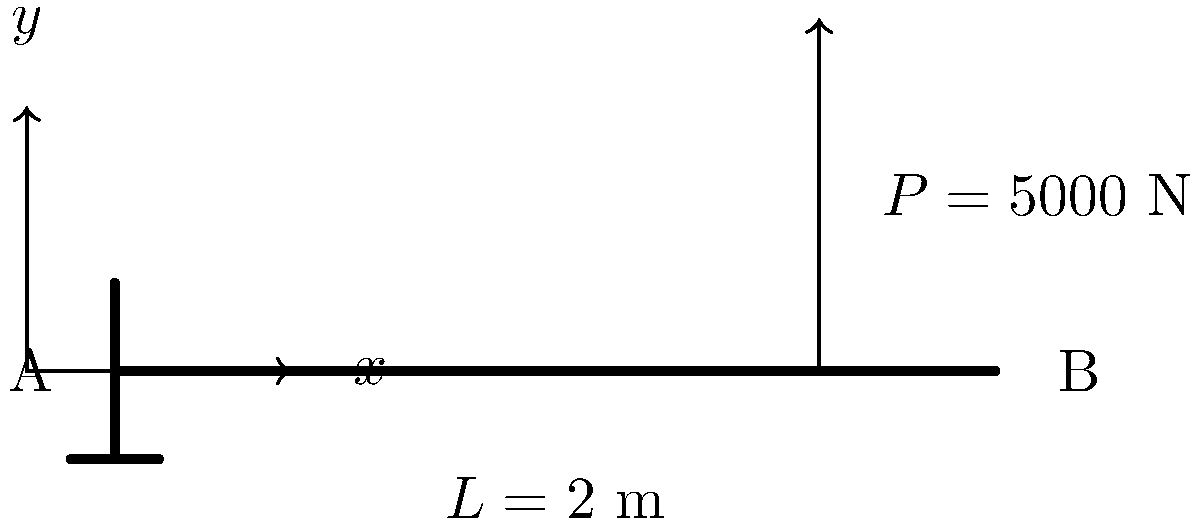As a business owner concerned with transparency in government contracts, you're reviewing a structural analysis report for a public building project. The report includes a problem involving a cantilever beam with a point load, as shown in the diagram. If the beam is made of steel with a yield strength of 250 MPa and a rectangular cross-section of 100 mm width and 200 mm height, determine the maximum bending stress at the fixed end (point A). Is the beam design safe with a factor of safety of 2? Let's approach this step-by-step:

1) First, we need to calculate the maximum bending moment. For a cantilever beam with a point load P at distance L from the fixed end:

   $M_{max} = PL$

   Where P = 5000 N and L = 2 m
   
   $M_{max} = 5000 \text{ N} \times 2 \text{ m} = 10000 \text{ N}\cdot\text{m}$

2) Next, we calculate the moment of inertia (I) for the rectangular cross-section:

   $I = \frac{bh^3}{12}$

   Where b = 100 mm and h = 200 mm

   $I = \frac{100 \text{ mm} \times (200 \text{ mm})^3}{12} = 66.67 \times 10^6 \text{ mm}^4$

3) Now we can calculate the maximum bending stress using the flexure formula:

   $\sigma_{max} = \frac{M_{max}y}{I}$

   Where y is half the beam height (100 mm)

   $\sigma_{max} = \frac{10000 \text{ N}\cdot\text{m} \times 0.1 \text{ m}}{66.67 \times 10^{-6} \text{ m}^4} = 150 \text{ MPa}$

4) To determine if the design is safe, we compare the maximum stress to the allowable stress:

   Allowable stress = Yield strength / Factor of safety
   $\sigma_{allowable} = 250 \text{ MPa} / 2 = 125 \text{ MPa}$

5) Since $\sigma_{max} (150 \text{ MPa}) > \sigma_{allowable} (125 \text{ MPa})$, the beam design is not safe with the given factor of safety.
Answer: 150 MPa; Not safe 